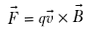<formula> <loc_0><loc_0><loc_500><loc_500>\vec { F } = q \vec { v } \times \vec { B }</formula> 